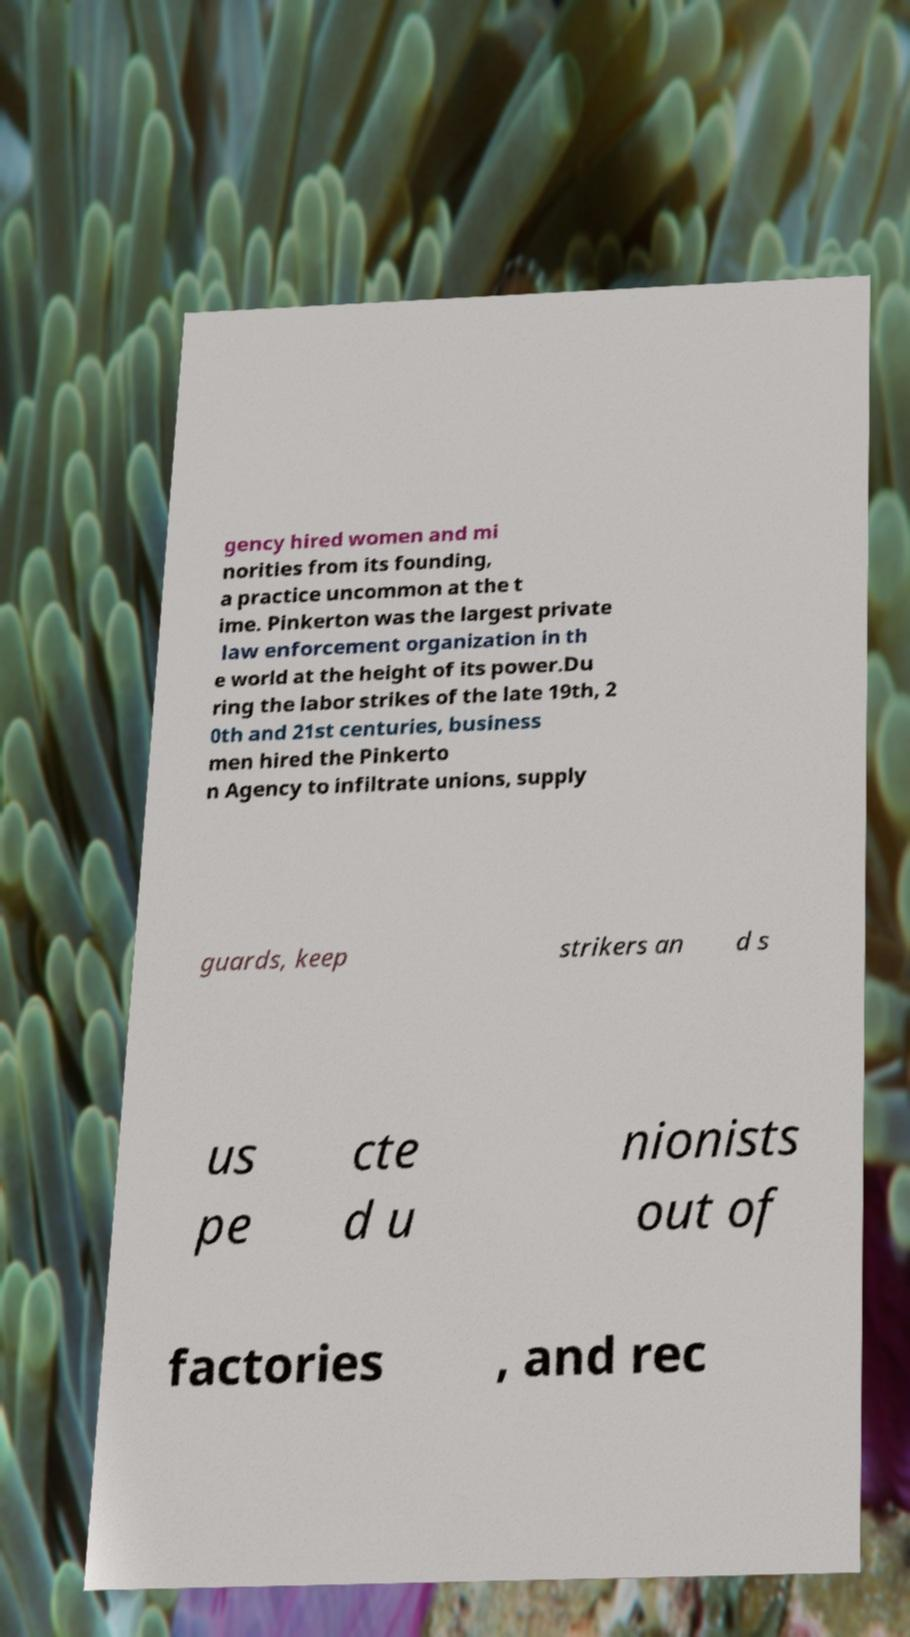Could you extract and type out the text from this image? gency hired women and mi norities from its founding, a practice uncommon at the t ime. Pinkerton was the largest private law enforcement organization in th e world at the height of its power.Du ring the labor strikes of the late 19th, 2 0th and 21st centuries, business men hired the Pinkerto n Agency to infiltrate unions, supply guards, keep strikers an d s us pe cte d u nionists out of factories , and rec 